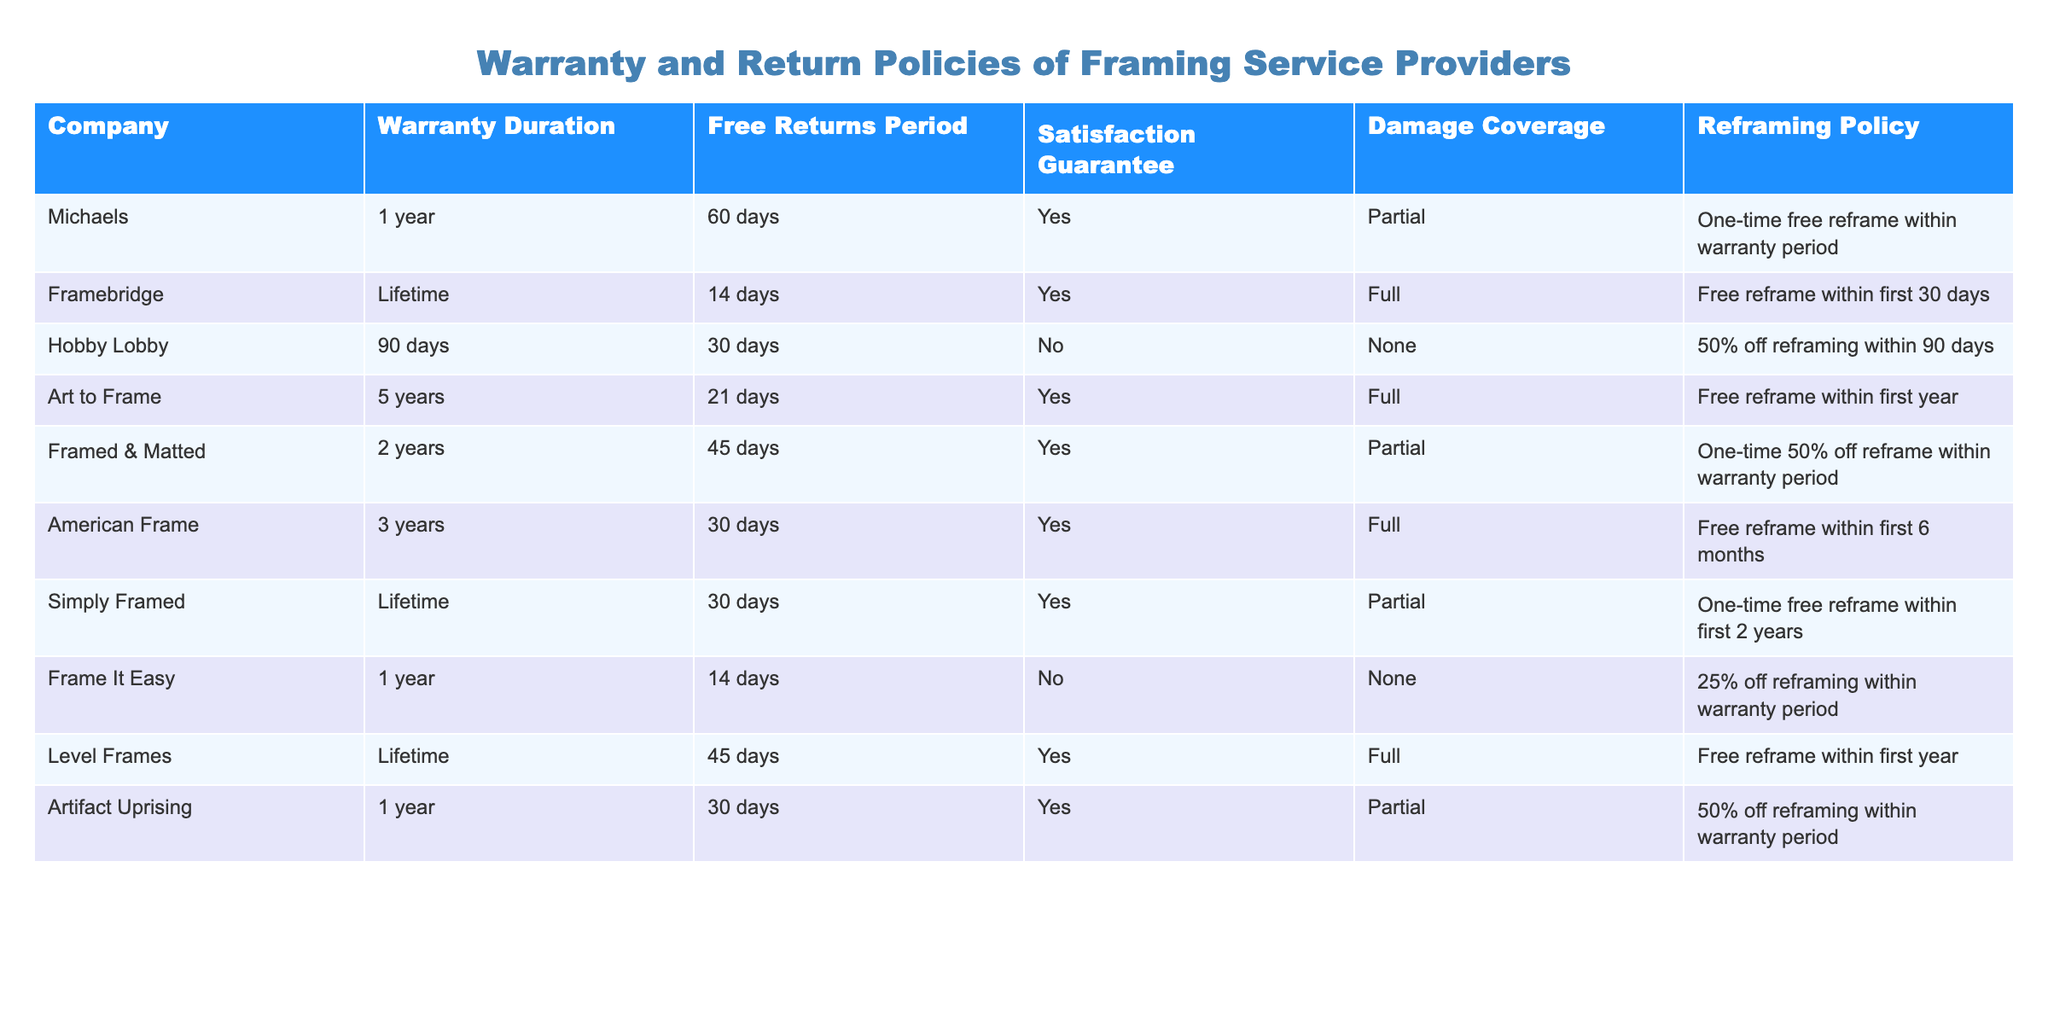What is the warranty duration for Framebridge? According to the table, Framebridge has a warranty duration of "Lifetime."
Answer: Lifetime How many companies provide a satisfaction guarantee? By counting the "Yes" entries in the Satisfaction Guarantee column, there are five companies that provide a satisfaction guarantee: Michaels, Framebridge, Art to Frame, Framed & Matted, and American Frame.
Answer: 5 Is there any company that offers free returns for more than 60 days? The table shows that only Framebridge and Level Frames offer free returns for "Lifetime" and "45 days," respectively; therefore, none offer free returns for more than 60 days.
Answer: No Which company has the longest warranty duration? Framebridge and Level Frames both have a "Lifetime" warranty duration, making them the companies with the longest coverage.
Answer: Framebridge and Level Frames What is the average warranty duration of the companies in the table? The warranty durations in years can be calculated as follows: Michaels (1), Framebridge (Lifetime=assumed as 100), Hobby Lobby (0.25), Art to Frame (5), Framed & Matted (2), American Frame (3), Simply Framed (Lifetime=100), Frame It Easy (1), Level Frames (Lifetime=100), Artifact Uprising (1). The average is (1 + 100 + 0.25 + 5 + 2 + 3 + 100 + 1 + 100 + 1) / 10 = 31.525 years.
Answer: 31.525 years Which company offers full damage coverage? The companies that offer full damage coverage are Framebridge, Art to Frame, American Frame, and Level Frames.
Answer: 4 Do any companies allow customers to reframe their artwork for free after the warranty period? Looking at the Reframing Policy column, only one company (Framebridge) allows free reframing within the first 30 days after purchase; all others restrict it during the warranty period.
Answer: No 